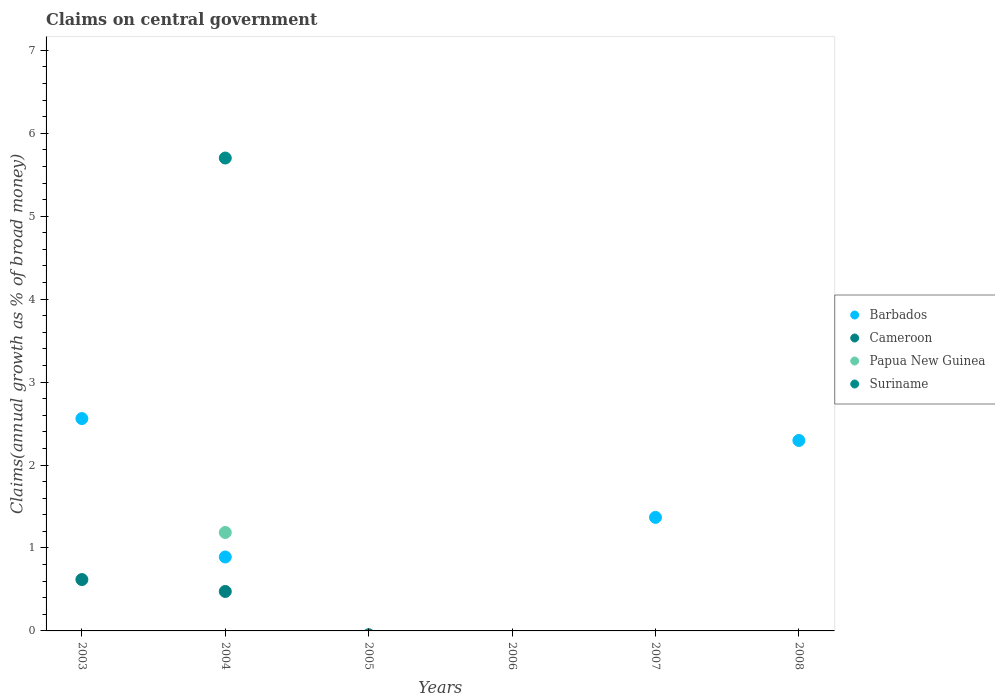Across all years, what is the maximum percentage of broad money claimed on centeral government in Papua New Guinea?
Provide a short and direct response. 1.19. In which year was the percentage of broad money claimed on centeral government in Suriname maximum?
Make the answer very short. 2004. What is the total percentage of broad money claimed on centeral government in Suriname in the graph?
Your answer should be very brief. 5.7. What is the difference between the percentage of broad money claimed on centeral government in Barbados in 2004 and that in 2007?
Ensure brevity in your answer.  -0.48. What is the difference between the percentage of broad money claimed on centeral government in Papua New Guinea in 2006 and the percentage of broad money claimed on centeral government in Barbados in 2003?
Offer a terse response. -2.56. What is the average percentage of broad money claimed on centeral government in Cameroon per year?
Your response must be concise. 0.18. In the year 2004, what is the difference between the percentage of broad money claimed on centeral government in Cameroon and percentage of broad money claimed on centeral government in Papua New Guinea?
Your answer should be very brief. -0.71. What is the ratio of the percentage of broad money claimed on centeral government in Barbados in 2003 to that in 2008?
Give a very brief answer. 1.11. What is the difference between the highest and the lowest percentage of broad money claimed on centeral government in Cameroon?
Offer a terse response. 0.62. Is it the case that in every year, the sum of the percentage of broad money claimed on centeral government in Suriname and percentage of broad money claimed on centeral government in Papua New Guinea  is greater than the sum of percentage of broad money claimed on centeral government in Barbados and percentage of broad money claimed on centeral government in Cameroon?
Give a very brief answer. No. Is it the case that in every year, the sum of the percentage of broad money claimed on centeral government in Barbados and percentage of broad money claimed on centeral government in Suriname  is greater than the percentage of broad money claimed on centeral government in Cameroon?
Give a very brief answer. No. Does the percentage of broad money claimed on centeral government in Cameroon monotonically increase over the years?
Make the answer very short. No. How many years are there in the graph?
Keep it short and to the point. 6. How many legend labels are there?
Give a very brief answer. 4. What is the title of the graph?
Keep it short and to the point. Claims on central government. Does "Venezuela" appear as one of the legend labels in the graph?
Keep it short and to the point. No. What is the label or title of the X-axis?
Your answer should be very brief. Years. What is the label or title of the Y-axis?
Provide a short and direct response. Claims(annual growth as % of broad money). What is the Claims(annual growth as % of broad money) in Barbados in 2003?
Keep it short and to the point. 2.56. What is the Claims(annual growth as % of broad money) of Cameroon in 2003?
Your response must be concise. 0.62. What is the Claims(annual growth as % of broad money) in Papua New Guinea in 2003?
Provide a succinct answer. 0. What is the Claims(annual growth as % of broad money) in Barbados in 2004?
Your response must be concise. 0.89. What is the Claims(annual growth as % of broad money) in Cameroon in 2004?
Ensure brevity in your answer.  0.48. What is the Claims(annual growth as % of broad money) in Papua New Guinea in 2004?
Keep it short and to the point. 1.19. What is the Claims(annual growth as % of broad money) in Suriname in 2004?
Offer a terse response. 5.7. What is the Claims(annual growth as % of broad money) of Barbados in 2005?
Ensure brevity in your answer.  0. What is the Claims(annual growth as % of broad money) in Cameroon in 2005?
Keep it short and to the point. 0. What is the Claims(annual growth as % of broad money) in Papua New Guinea in 2005?
Make the answer very short. 0. What is the Claims(annual growth as % of broad money) of Cameroon in 2006?
Give a very brief answer. 0. What is the Claims(annual growth as % of broad money) of Suriname in 2006?
Give a very brief answer. 0. What is the Claims(annual growth as % of broad money) of Barbados in 2007?
Ensure brevity in your answer.  1.37. What is the Claims(annual growth as % of broad money) of Cameroon in 2007?
Give a very brief answer. 0. What is the Claims(annual growth as % of broad money) of Barbados in 2008?
Offer a very short reply. 2.3. What is the Claims(annual growth as % of broad money) in Papua New Guinea in 2008?
Provide a short and direct response. 0. What is the Claims(annual growth as % of broad money) in Suriname in 2008?
Make the answer very short. 0. Across all years, what is the maximum Claims(annual growth as % of broad money) in Barbados?
Keep it short and to the point. 2.56. Across all years, what is the maximum Claims(annual growth as % of broad money) of Cameroon?
Keep it short and to the point. 0.62. Across all years, what is the maximum Claims(annual growth as % of broad money) of Papua New Guinea?
Provide a succinct answer. 1.19. Across all years, what is the maximum Claims(annual growth as % of broad money) of Suriname?
Your answer should be compact. 5.7. Across all years, what is the minimum Claims(annual growth as % of broad money) in Cameroon?
Provide a short and direct response. 0. Across all years, what is the minimum Claims(annual growth as % of broad money) of Suriname?
Keep it short and to the point. 0. What is the total Claims(annual growth as % of broad money) of Barbados in the graph?
Provide a short and direct response. 7.12. What is the total Claims(annual growth as % of broad money) of Cameroon in the graph?
Your answer should be compact. 1.09. What is the total Claims(annual growth as % of broad money) in Papua New Guinea in the graph?
Your response must be concise. 1.19. What is the total Claims(annual growth as % of broad money) of Suriname in the graph?
Your response must be concise. 5.7. What is the difference between the Claims(annual growth as % of broad money) of Barbados in 2003 and that in 2004?
Give a very brief answer. 1.67. What is the difference between the Claims(annual growth as % of broad money) in Cameroon in 2003 and that in 2004?
Offer a terse response. 0.14. What is the difference between the Claims(annual growth as % of broad money) of Barbados in 2003 and that in 2007?
Provide a short and direct response. 1.19. What is the difference between the Claims(annual growth as % of broad money) in Barbados in 2003 and that in 2008?
Your answer should be very brief. 0.26. What is the difference between the Claims(annual growth as % of broad money) in Barbados in 2004 and that in 2007?
Ensure brevity in your answer.  -0.48. What is the difference between the Claims(annual growth as % of broad money) of Barbados in 2004 and that in 2008?
Offer a very short reply. -1.4. What is the difference between the Claims(annual growth as % of broad money) in Barbados in 2007 and that in 2008?
Your answer should be compact. -0.93. What is the difference between the Claims(annual growth as % of broad money) in Barbados in 2003 and the Claims(annual growth as % of broad money) in Cameroon in 2004?
Ensure brevity in your answer.  2.08. What is the difference between the Claims(annual growth as % of broad money) in Barbados in 2003 and the Claims(annual growth as % of broad money) in Papua New Guinea in 2004?
Offer a terse response. 1.37. What is the difference between the Claims(annual growth as % of broad money) of Barbados in 2003 and the Claims(annual growth as % of broad money) of Suriname in 2004?
Your response must be concise. -3.14. What is the difference between the Claims(annual growth as % of broad money) of Cameroon in 2003 and the Claims(annual growth as % of broad money) of Papua New Guinea in 2004?
Your answer should be very brief. -0.57. What is the difference between the Claims(annual growth as % of broad money) in Cameroon in 2003 and the Claims(annual growth as % of broad money) in Suriname in 2004?
Your response must be concise. -5.08. What is the average Claims(annual growth as % of broad money) in Barbados per year?
Offer a very short reply. 1.19. What is the average Claims(annual growth as % of broad money) in Cameroon per year?
Keep it short and to the point. 0.18. What is the average Claims(annual growth as % of broad money) in Papua New Guinea per year?
Ensure brevity in your answer.  0.2. What is the average Claims(annual growth as % of broad money) in Suriname per year?
Give a very brief answer. 0.95. In the year 2003, what is the difference between the Claims(annual growth as % of broad money) in Barbados and Claims(annual growth as % of broad money) in Cameroon?
Your response must be concise. 1.94. In the year 2004, what is the difference between the Claims(annual growth as % of broad money) of Barbados and Claims(annual growth as % of broad money) of Cameroon?
Your answer should be compact. 0.42. In the year 2004, what is the difference between the Claims(annual growth as % of broad money) of Barbados and Claims(annual growth as % of broad money) of Papua New Guinea?
Give a very brief answer. -0.3. In the year 2004, what is the difference between the Claims(annual growth as % of broad money) in Barbados and Claims(annual growth as % of broad money) in Suriname?
Your answer should be compact. -4.81. In the year 2004, what is the difference between the Claims(annual growth as % of broad money) of Cameroon and Claims(annual growth as % of broad money) of Papua New Guinea?
Give a very brief answer. -0.71. In the year 2004, what is the difference between the Claims(annual growth as % of broad money) in Cameroon and Claims(annual growth as % of broad money) in Suriname?
Make the answer very short. -5.23. In the year 2004, what is the difference between the Claims(annual growth as % of broad money) of Papua New Guinea and Claims(annual growth as % of broad money) of Suriname?
Your answer should be very brief. -4.51. What is the ratio of the Claims(annual growth as % of broad money) in Barbados in 2003 to that in 2004?
Offer a very short reply. 2.87. What is the ratio of the Claims(annual growth as % of broad money) in Cameroon in 2003 to that in 2004?
Keep it short and to the point. 1.3. What is the ratio of the Claims(annual growth as % of broad money) of Barbados in 2003 to that in 2007?
Your answer should be compact. 1.87. What is the ratio of the Claims(annual growth as % of broad money) of Barbados in 2003 to that in 2008?
Your answer should be very brief. 1.11. What is the ratio of the Claims(annual growth as % of broad money) in Barbados in 2004 to that in 2007?
Offer a terse response. 0.65. What is the ratio of the Claims(annual growth as % of broad money) in Barbados in 2004 to that in 2008?
Your answer should be very brief. 0.39. What is the ratio of the Claims(annual growth as % of broad money) of Barbados in 2007 to that in 2008?
Your answer should be very brief. 0.6. What is the difference between the highest and the second highest Claims(annual growth as % of broad money) of Barbados?
Give a very brief answer. 0.26. What is the difference between the highest and the lowest Claims(annual growth as % of broad money) in Barbados?
Your answer should be compact. 2.56. What is the difference between the highest and the lowest Claims(annual growth as % of broad money) of Cameroon?
Give a very brief answer. 0.62. What is the difference between the highest and the lowest Claims(annual growth as % of broad money) of Papua New Guinea?
Keep it short and to the point. 1.19. What is the difference between the highest and the lowest Claims(annual growth as % of broad money) of Suriname?
Provide a short and direct response. 5.7. 